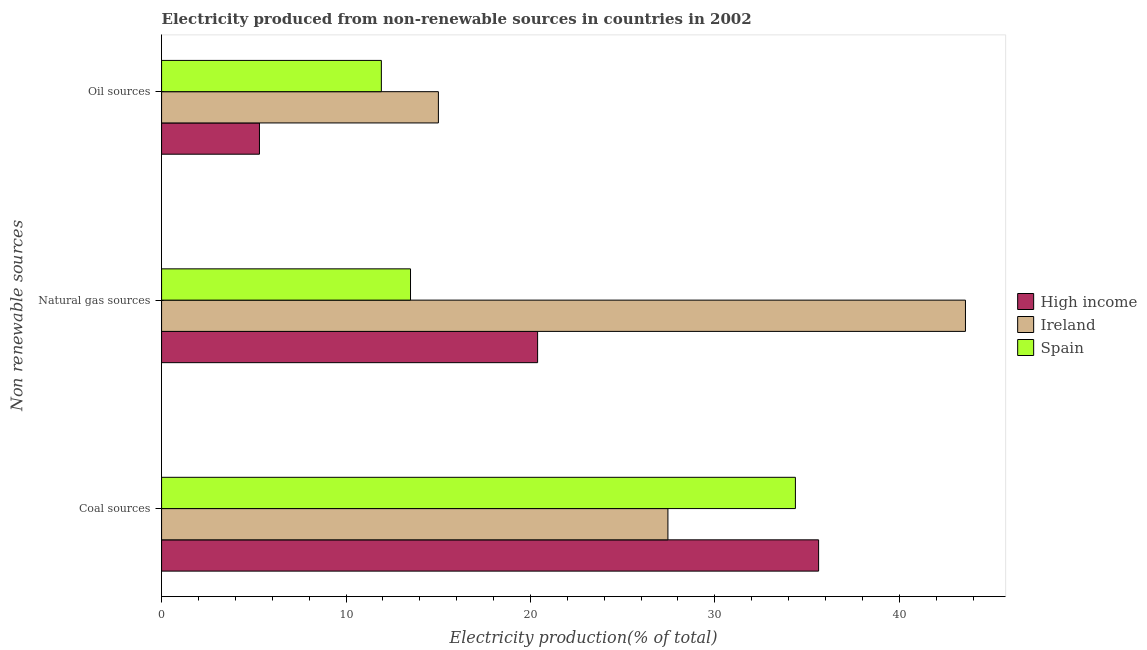How many different coloured bars are there?
Offer a terse response. 3. How many groups of bars are there?
Make the answer very short. 3. Are the number of bars per tick equal to the number of legend labels?
Offer a terse response. Yes. Are the number of bars on each tick of the Y-axis equal?
Provide a short and direct response. Yes. How many bars are there on the 3rd tick from the top?
Provide a succinct answer. 3. What is the label of the 3rd group of bars from the top?
Your answer should be very brief. Coal sources. What is the percentage of electricity produced by coal in Spain?
Offer a very short reply. 34.37. Across all countries, what is the maximum percentage of electricity produced by coal?
Offer a terse response. 35.63. Across all countries, what is the minimum percentage of electricity produced by coal?
Offer a very short reply. 27.46. What is the total percentage of electricity produced by oil sources in the graph?
Make the answer very short. 32.24. What is the difference between the percentage of electricity produced by natural gas in High income and that in Ireland?
Make the answer very short. -23.2. What is the difference between the percentage of electricity produced by oil sources in Spain and the percentage of electricity produced by coal in Ireland?
Provide a short and direct response. -15.54. What is the average percentage of electricity produced by coal per country?
Provide a succinct answer. 32.48. What is the difference between the percentage of electricity produced by coal and percentage of electricity produced by natural gas in Spain?
Offer a terse response. 20.87. What is the ratio of the percentage of electricity produced by oil sources in Ireland to that in High income?
Your answer should be very brief. 2.83. Is the percentage of electricity produced by oil sources in Ireland less than that in High income?
Offer a very short reply. No. Is the difference between the percentage of electricity produced by natural gas in Ireland and Spain greater than the difference between the percentage of electricity produced by coal in Ireland and Spain?
Offer a terse response. Yes. What is the difference between the highest and the second highest percentage of electricity produced by oil sources?
Provide a succinct answer. 3.09. What is the difference between the highest and the lowest percentage of electricity produced by oil sources?
Give a very brief answer. 9.7. In how many countries, is the percentage of electricity produced by natural gas greater than the average percentage of electricity produced by natural gas taken over all countries?
Make the answer very short. 1. What does the 2nd bar from the bottom in Natural gas sources represents?
Keep it short and to the point. Ireland. Is it the case that in every country, the sum of the percentage of electricity produced by coal and percentage of electricity produced by natural gas is greater than the percentage of electricity produced by oil sources?
Your response must be concise. Yes. How many bars are there?
Your response must be concise. 9. What is the difference between two consecutive major ticks on the X-axis?
Your answer should be very brief. 10. Are the values on the major ticks of X-axis written in scientific E-notation?
Provide a succinct answer. No. Does the graph contain any zero values?
Your answer should be very brief. No. Does the graph contain grids?
Your response must be concise. No. How many legend labels are there?
Offer a terse response. 3. How are the legend labels stacked?
Offer a very short reply. Vertical. What is the title of the graph?
Ensure brevity in your answer.  Electricity produced from non-renewable sources in countries in 2002. What is the label or title of the Y-axis?
Your answer should be compact. Non renewable sources. What is the Electricity production(% of total) in High income in Coal sources?
Your response must be concise. 35.63. What is the Electricity production(% of total) of Ireland in Coal sources?
Ensure brevity in your answer.  27.46. What is the Electricity production(% of total) of Spain in Coal sources?
Your answer should be very brief. 34.37. What is the Electricity production(% of total) in High income in Natural gas sources?
Give a very brief answer. 20.39. What is the Electricity production(% of total) of Ireland in Natural gas sources?
Offer a very short reply. 43.59. What is the Electricity production(% of total) of Spain in Natural gas sources?
Your response must be concise. 13.5. What is the Electricity production(% of total) of High income in Oil sources?
Provide a succinct answer. 5.31. What is the Electricity production(% of total) of Ireland in Oil sources?
Keep it short and to the point. 15.01. What is the Electricity production(% of total) of Spain in Oil sources?
Ensure brevity in your answer.  11.92. Across all Non renewable sources, what is the maximum Electricity production(% of total) of High income?
Ensure brevity in your answer.  35.63. Across all Non renewable sources, what is the maximum Electricity production(% of total) in Ireland?
Provide a succinct answer. 43.59. Across all Non renewable sources, what is the maximum Electricity production(% of total) in Spain?
Your response must be concise. 34.37. Across all Non renewable sources, what is the minimum Electricity production(% of total) of High income?
Ensure brevity in your answer.  5.31. Across all Non renewable sources, what is the minimum Electricity production(% of total) of Ireland?
Keep it short and to the point. 15.01. Across all Non renewable sources, what is the minimum Electricity production(% of total) of Spain?
Provide a short and direct response. 11.92. What is the total Electricity production(% of total) in High income in the graph?
Your response must be concise. 61.32. What is the total Electricity production(% of total) of Ireland in the graph?
Keep it short and to the point. 86.06. What is the total Electricity production(% of total) of Spain in the graph?
Keep it short and to the point. 59.79. What is the difference between the Electricity production(% of total) in High income in Coal sources and that in Natural gas sources?
Your response must be concise. 15.24. What is the difference between the Electricity production(% of total) in Ireland in Coal sources and that in Natural gas sources?
Your answer should be very brief. -16.13. What is the difference between the Electricity production(% of total) in Spain in Coal sources and that in Natural gas sources?
Ensure brevity in your answer.  20.87. What is the difference between the Electricity production(% of total) of High income in Coal sources and that in Oil sources?
Keep it short and to the point. 30.32. What is the difference between the Electricity production(% of total) of Ireland in Coal sources and that in Oil sources?
Offer a very short reply. 12.45. What is the difference between the Electricity production(% of total) of Spain in Coal sources and that in Oil sources?
Give a very brief answer. 22.45. What is the difference between the Electricity production(% of total) in High income in Natural gas sources and that in Oil sources?
Give a very brief answer. 15.08. What is the difference between the Electricity production(% of total) in Ireland in Natural gas sources and that in Oil sources?
Offer a terse response. 28.58. What is the difference between the Electricity production(% of total) of Spain in Natural gas sources and that in Oil sources?
Give a very brief answer. 1.58. What is the difference between the Electricity production(% of total) of High income in Coal sources and the Electricity production(% of total) of Ireland in Natural gas sources?
Make the answer very short. -7.96. What is the difference between the Electricity production(% of total) of High income in Coal sources and the Electricity production(% of total) of Spain in Natural gas sources?
Provide a succinct answer. 22.13. What is the difference between the Electricity production(% of total) of Ireland in Coal sources and the Electricity production(% of total) of Spain in Natural gas sources?
Give a very brief answer. 13.96. What is the difference between the Electricity production(% of total) in High income in Coal sources and the Electricity production(% of total) in Ireland in Oil sources?
Make the answer very short. 20.62. What is the difference between the Electricity production(% of total) in High income in Coal sources and the Electricity production(% of total) in Spain in Oil sources?
Keep it short and to the point. 23.71. What is the difference between the Electricity production(% of total) of Ireland in Coal sources and the Electricity production(% of total) of Spain in Oil sources?
Keep it short and to the point. 15.54. What is the difference between the Electricity production(% of total) of High income in Natural gas sources and the Electricity production(% of total) of Ireland in Oil sources?
Offer a terse response. 5.38. What is the difference between the Electricity production(% of total) in High income in Natural gas sources and the Electricity production(% of total) in Spain in Oil sources?
Offer a very short reply. 8.47. What is the difference between the Electricity production(% of total) in Ireland in Natural gas sources and the Electricity production(% of total) in Spain in Oil sources?
Your answer should be compact. 31.67. What is the average Electricity production(% of total) in High income per Non renewable sources?
Offer a very short reply. 20.44. What is the average Electricity production(% of total) in Ireland per Non renewable sources?
Provide a succinct answer. 28.69. What is the average Electricity production(% of total) of Spain per Non renewable sources?
Your response must be concise. 19.93. What is the difference between the Electricity production(% of total) in High income and Electricity production(% of total) in Ireland in Coal sources?
Your response must be concise. 8.17. What is the difference between the Electricity production(% of total) of High income and Electricity production(% of total) of Spain in Coal sources?
Offer a terse response. 1.26. What is the difference between the Electricity production(% of total) of Ireland and Electricity production(% of total) of Spain in Coal sources?
Give a very brief answer. -6.91. What is the difference between the Electricity production(% of total) in High income and Electricity production(% of total) in Ireland in Natural gas sources?
Give a very brief answer. -23.2. What is the difference between the Electricity production(% of total) of High income and Electricity production(% of total) of Spain in Natural gas sources?
Your response must be concise. 6.89. What is the difference between the Electricity production(% of total) in Ireland and Electricity production(% of total) in Spain in Natural gas sources?
Your response must be concise. 30.09. What is the difference between the Electricity production(% of total) in High income and Electricity production(% of total) in Ireland in Oil sources?
Give a very brief answer. -9.7. What is the difference between the Electricity production(% of total) in High income and Electricity production(% of total) in Spain in Oil sources?
Give a very brief answer. -6.61. What is the difference between the Electricity production(% of total) of Ireland and Electricity production(% of total) of Spain in Oil sources?
Your answer should be compact. 3.09. What is the ratio of the Electricity production(% of total) in High income in Coal sources to that in Natural gas sources?
Make the answer very short. 1.75. What is the ratio of the Electricity production(% of total) in Ireland in Coal sources to that in Natural gas sources?
Ensure brevity in your answer.  0.63. What is the ratio of the Electricity production(% of total) in Spain in Coal sources to that in Natural gas sources?
Ensure brevity in your answer.  2.55. What is the ratio of the Electricity production(% of total) of High income in Coal sources to that in Oil sources?
Make the answer very short. 6.71. What is the ratio of the Electricity production(% of total) in Ireland in Coal sources to that in Oil sources?
Keep it short and to the point. 1.83. What is the ratio of the Electricity production(% of total) of Spain in Coal sources to that in Oil sources?
Keep it short and to the point. 2.88. What is the ratio of the Electricity production(% of total) in High income in Natural gas sources to that in Oil sources?
Your response must be concise. 3.84. What is the ratio of the Electricity production(% of total) in Ireland in Natural gas sources to that in Oil sources?
Ensure brevity in your answer.  2.9. What is the ratio of the Electricity production(% of total) in Spain in Natural gas sources to that in Oil sources?
Give a very brief answer. 1.13. What is the difference between the highest and the second highest Electricity production(% of total) of High income?
Offer a terse response. 15.24. What is the difference between the highest and the second highest Electricity production(% of total) of Ireland?
Offer a very short reply. 16.13. What is the difference between the highest and the second highest Electricity production(% of total) in Spain?
Give a very brief answer. 20.87. What is the difference between the highest and the lowest Electricity production(% of total) of High income?
Make the answer very short. 30.32. What is the difference between the highest and the lowest Electricity production(% of total) in Ireland?
Give a very brief answer. 28.58. What is the difference between the highest and the lowest Electricity production(% of total) in Spain?
Provide a succinct answer. 22.45. 